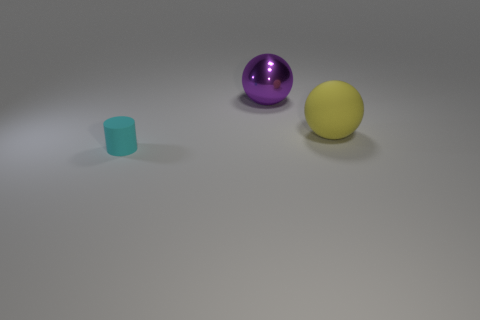Is there any other thing that has the same size as the cyan matte cylinder?
Give a very brief answer. No. There is a object that is both on the left side of the big yellow rubber sphere and behind the small cyan matte thing; what is its color?
Keep it short and to the point. Purple. There is a large ball that is behind the large rubber ball; how many big shiny balls are on the right side of it?
Provide a short and direct response. 0. There is a large yellow object that is the same shape as the large purple shiny thing; what material is it?
Make the answer very short. Rubber. The matte sphere is what color?
Keep it short and to the point. Yellow. What number of things are large purple rubber cubes or things?
Your answer should be compact. 3. What shape is the big object left of the matte thing that is behind the small rubber object?
Keep it short and to the point. Sphere. What number of other objects are there of the same material as the cyan cylinder?
Give a very brief answer. 1. Does the big purple object have the same material as the large ball in front of the shiny object?
Provide a short and direct response. No. What number of objects are balls that are in front of the purple thing or things right of the large shiny object?
Ensure brevity in your answer.  1. 